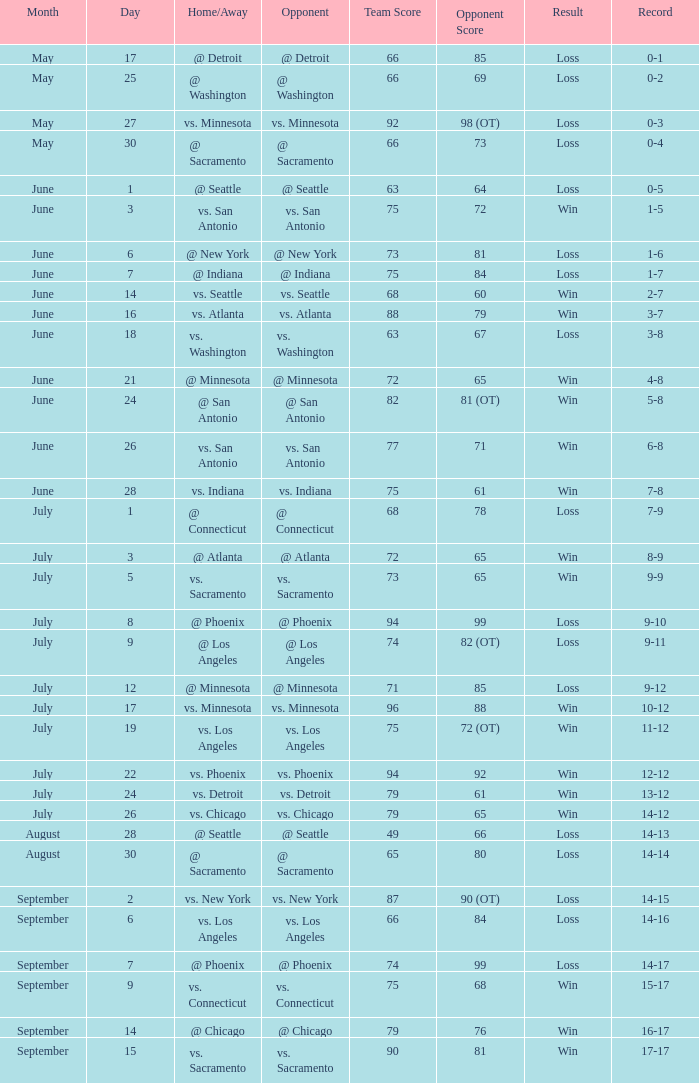What was the conclusion on may 30? Loss. 